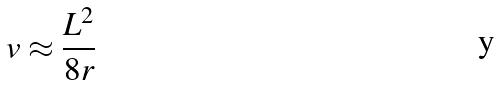Convert formula to latex. <formula><loc_0><loc_0><loc_500><loc_500>v \approx \frac { L ^ { 2 } } { 8 r }</formula> 